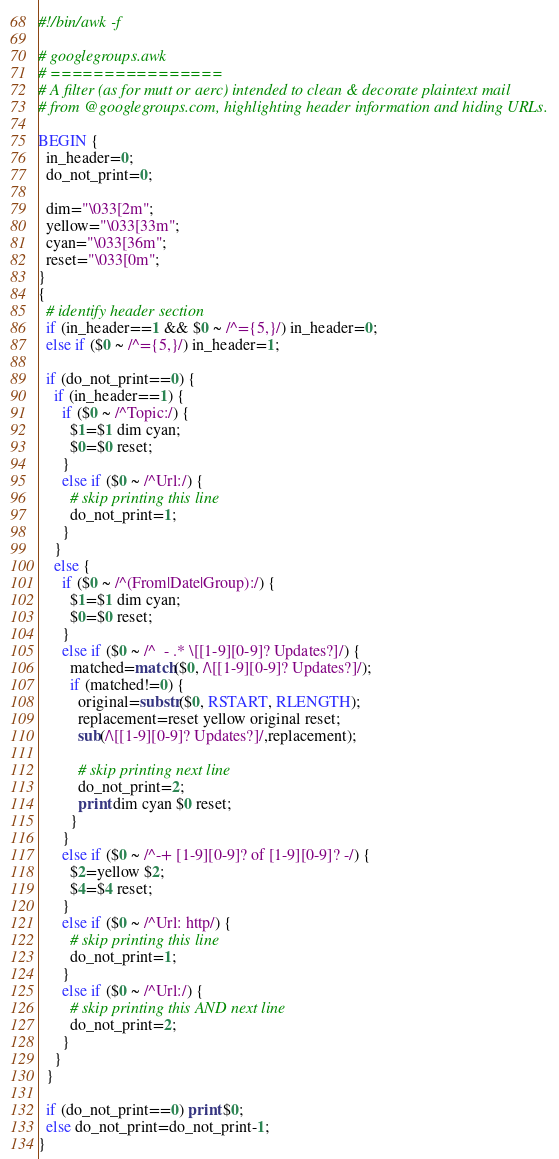<code> <loc_0><loc_0><loc_500><loc_500><_Awk_>#!/bin/awk -f

# googlegroups.awk
# ================
# A filter (as for mutt or aerc) intended to clean & decorate plaintext mail
# from @googlegroups.com, highlighting header information and hiding URLs.

BEGIN {
  in_header=0;
  do_not_print=0;

  dim="\033[2m";
  yellow="\033[33m";
  cyan="\033[36m";
  reset="\033[0m";
}
{
  # identify header section
  if (in_header==1 && $0 ~ /^={5,}/) in_header=0;
  else if ($0 ~ /^={5,}/) in_header=1;

  if (do_not_print==0) {
    if (in_header==1) {
      if ($0 ~ /^Topic:/) {
        $1=$1 dim cyan;
        $0=$0 reset;
      }
      else if ($0 ~ /^Url:/) {
        # skip printing this line
        do_not_print=1;
      }
    }
    else {
      if ($0 ~ /^(From|Date|Group):/) {
        $1=$1 dim cyan;
        $0=$0 reset;
      }
      else if ($0 ~ /^  - .* \[[1-9][0-9]? Updates?]/) {
        matched=match($0, /\[[1-9][0-9]? Updates?]/);
        if (matched!=0) {
          original=substr($0, RSTART, RLENGTH);
          replacement=reset yellow original reset;
          sub(/\[[1-9][0-9]? Updates?]/,replacement);

          # skip printing next line
          do_not_print=2;
          print dim cyan $0 reset;
        }
      }
      else if ($0 ~ /^-+ [1-9][0-9]? of [1-9][0-9]? -/) {
        $2=yellow $2;
        $4=$4 reset;
      }
      else if ($0 ~ /^Url: http/) {
        # skip printing this line
        do_not_print=1;
      }
      else if ($0 ~ /^Url:/) {
        # skip printing this AND next line
        do_not_print=2;
      }
    }
  }

  if (do_not_print==0) print $0;
  else do_not_print=do_not_print-1;
}


</code> 